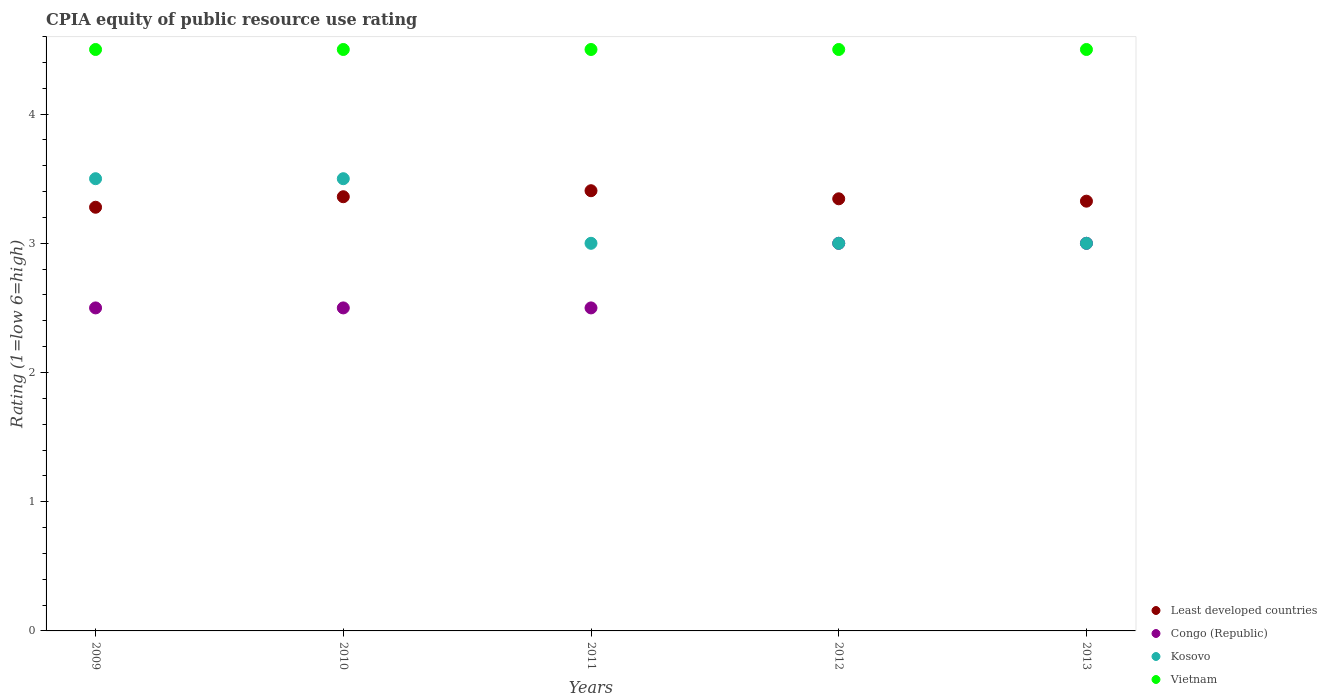How many different coloured dotlines are there?
Offer a terse response. 4. What is the CPIA rating in Least developed countries in 2009?
Your answer should be very brief. 3.28. Across all years, what is the minimum CPIA rating in Vietnam?
Provide a short and direct response. 4.5. In which year was the CPIA rating in Kosovo maximum?
Provide a succinct answer. 2009. In which year was the CPIA rating in Congo (Republic) minimum?
Your answer should be very brief. 2009. What is the difference between the CPIA rating in Least developed countries in 2011 and that in 2013?
Make the answer very short. 0.08. What is the average CPIA rating in Least developed countries per year?
Provide a succinct answer. 3.34. In the year 2010, what is the difference between the CPIA rating in Congo (Republic) and CPIA rating in Vietnam?
Provide a succinct answer. -2. Is the difference between the CPIA rating in Congo (Republic) in 2011 and 2012 greater than the difference between the CPIA rating in Vietnam in 2011 and 2012?
Provide a short and direct response. No. What is the difference between the highest and the lowest CPIA rating in Vietnam?
Your answer should be compact. 0. Is the sum of the CPIA rating in Congo (Republic) in 2010 and 2013 greater than the maximum CPIA rating in Least developed countries across all years?
Ensure brevity in your answer.  Yes. Is it the case that in every year, the sum of the CPIA rating in Congo (Republic) and CPIA rating in Kosovo  is greater than the CPIA rating in Least developed countries?
Make the answer very short. Yes. Are the values on the major ticks of Y-axis written in scientific E-notation?
Your answer should be very brief. No. How are the legend labels stacked?
Your response must be concise. Vertical. What is the title of the graph?
Provide a short and direct response. CPIA equity of public resource use rating. What is the label or title of the Y-axis?
Make the answer very short. Rating (1=low 6=high). What is the Rating (1=low 6=high) in Least developed countries in 2009?
Your answer should be compact. 3.28. What is the Rating (1=low 6=high) in Vietnam in 2009?
Provide a succinct answer. 4.5. What is the Rating (1=low 6=high) in Least developed countries in 2010?
Provide a succinct answer. 3.36. What is the Rating (1=low 6=high) in Least developed countries in 2011?
Offer a very short reply. 3.41. What is the Rating (1=low 6=high) in Vietnam in 2011?
Your answer should be compact. 4.5. What is the Rating (1=low 6=high) in Least developed countries in 2012?
Give a very brief answer. 3.34. What is the Rating (1=low 6=high) of Congo (Republic) in 2012?
Provide a short and direct response. 3. What is the Rating (1=low 6=high) of Vietnam in 2012?
Offer a terse response. 4.5. What is the Rating (1=low 6=high) in Least developed countries in 2013?
Ensure brevity in your answer.  3.33. What is the Rating (1=low 6=high) of Vietnam in 2013?
Give a very brief answer. 4.5. Across all years, what is the maximum Rating (1=low 6=high) of Least developed countries?
Offer a terse response. 3.41. Across all years, what is the maximum Rating (1=low 6=high) in Kosovo?
Your answer should be compact. 3.5. Across all years, what is the maximum Rating (1=low 6=high) of Vietnam?
Offer a terse response. 4.5. Across all years, what is the minimum Rating (1=low 6=high) in Least developed countries?
Offer a very short reply. 3.28. Across all years, what is the minimum Rating (1=low 6=high) of Vietnam?
Offer a very short reply. 4.5. What is the total Rating (1=low 6=high) of Least developed countries in the graph?
Keep it short and to the point. 16.72. What is the total Rating (1=low 6=high) of Congo (Republic) in the graph?
Ensure brevity in your answer.  13.5. What is the total Rating (1=low 6=high) in Vietnam in the graph?
Your answer should be very brief. 22.5. What is the difference between the Rating (1=low 6=high) of Least developed countries in 2009 and that in 2010?
Ensure brevity in your answer.  -0.08. What is the difference between the Rating (1=low 6=high) in Congo (Republic) in 2009 and that in 2010?
Provide a short and direct response. 0. What is the difference between the Rating (1=low 6=high) of Kosovo in 2009 and that in 2010?
Give a very brief answer. 0. What is the difference between the Rating (1=low 6=high) in Vietnam in 2009 and that in 2010?
Make the answer very short. 0. What is the difference between the Rating (1=low 6=high) of Least developed countries in 2009 and that in 2011?
Give a very brief answer. -0.13. What is the difference between the Rating (1=low 6=high) of Vietnam in 2009 and that in 2011?
Offer a very short reply. 0. What is the difference between the Rating (1=low 6=high) in Least developed countries in 2009 and that in 2012?
Provide a short and direct response. -0.07. What is the difference between the Rating (1=low 6=high) of Least developed countries in 2009 and that in 2013?
Your answer should be very brief. -0.05. What is the difference between the Rating (1=low 6=high) in Kosovo in 2009 and that in 2013?
Ensure brevity in your answer.  0.5. What is the difference between the Rating (1=low 6=high) of Least developed countries in 2010 and that in 2011?
Make the answer very short. -0.05. What is the difference between the Rating (1=low 6=high) of Least developed countries in 2010 and that in 2012?
Ensure brevity in your answer.  0.02. What is the difference between the Rating (1=low 6=high) in Vietnam in 2010 and that in 2012?
Ensure brevity in your answer.  0. What is the difference between the Rating (1=low 6=high) of Least developed countries in 2010 and that in 2013?
Give a very brief answer. 0.03. What is the difference between the Rating (1=low 6=high) in Congo (Republic) in 2010 and that in 2013?
Make the answer very short. -0.5. What is the difference between the Rating (1=low 6=high) of Vietnam in 2010 and that in 2013?
Your answer should be compact. 0. What is the difference between the Rating (1=low 6=high) of Least developed countries in 2011 and that in 2012?
Offer a terse response. 0.06. What is the difference between the Rating (1=low 6=high) in Congo (Republic) in 2011 and that in 2012?
Your response must be concise. -0.5. What is the difference between the Rating (1=low 6=high) in Kosovo in 2011 and that in 2012?
Your answer should be compact. 0. What is the difference between the Rating (1=low 6=high) in Least developed countries in 2011 and that in 2013?
Make the answer very short. 0.08. What is the difference between the Rating (1=low 6=high) in Congo (Republic) in 2011 and that in 2013?
Offer a very short reply. -0.5. What is the difference between the Rating (1=low 6=high) of Least developed countries in 2012 and that in 2013?
Your response must be concise. 0.02. What is the difference between the Rating (1=low 6=high) of Kosovo in 2012 and that in 2013?
Your response must be concise. 0. What is the difference between the Rating (1=low 6=high) of Least developed countries in 2009 and the Rating (1=low 6=high) of Congo (Republic) in 2010?
Make the answer very short. 0.78. What is the difference between the Rating (1=low 6=high) in Least developed countries in 2009 and the Rating (1=low 6=high) in Kosovo in 2010?
Provide a short and direct response. -0.22. What is the difference between the Rating (1=low 6=high) in Least developed countries in 2009 and the Rating (1=low 6=high) in Vietnam in 2010?
Make the answer very short. -1.22. What is the difference between the Rating (1=low 6=high) of Congo (Republic) in 2009 and the Rating (1=low 6=high) of Kosovo in 2010?
Your response must be concise. -1. What is the difference between the Rating (1=low 6=high) in Kosovo in 2009 and the Rating (1=low 6=high) in Vietnam in 2010?
Make the answer very short. -1. What is the difference between the Rating (1=low 6=high) of Least developed countries in 2009 and the Rating (1=low 6=high) of Congo (Republic) in 2011?
Your response must be concise. 0.78. What is the difference between the Rating (1=low 6=high) in Least developed countries in 2009 and the Rating (1=low 6=high) in Kosovo in 2011?
Provide a succinct answer. 0.28. What is the difference between the Rating (1=low 6=high) in Least developed countries in 2009 and the Rating (1=low 6=high) in Vietnam in 2011?
Provide a succinct answer. -1.22. What is the difference between the Rating (1=low 6=high) in Congo (Republic) in 2009 and the Rating (1=low 6=high) in Kosovo in 2011?
Your answer should be very brief. -0.5. What is the difference between the Rating (1=low 6=high) of Least developed countries in 2009 and the Rating (1=low 6=high) of Congo (Republic) in 2012?
Offer a terse response. 0.28. What is the difference between the Rating (1=low 6=high) of Least developed countries in 2009 and the Rating (1=low 6=high) of Kosovo in 2012?
Keep it short and to the point. 0.28. What is the difference between the Rating (1=low 6=high) in Least developed countries in 2009 and the Rating (1=low 6=high) in Vietnam in 2012?
Provide a short and direct response. -1.22. What is the difference between the Rating (1=low 6=high) in Congo (Republic) in 2009 and the Rating (1=low 6=high) in Kosovo in 2012?
Provide a succinct answer. -0.5. What is the difference between the Rating (1=low 6=high) of Congo (Republic) in 2009 and the Rating (1=low 6=high) of Vietnam in 2012?
Offer a terse response. -2. What is the difference between the Rating (1=low 6=high) of Kosovo in 2009 and the Rating (1=low 6=high) of Vietnam in 2012?
Your answer should be compact. -1. What is the difference between the Rating (1=low 6=high) of Least developed countries in 2009 and the Rating (1=low 6=high) of Congo (Republic) in 2013?
Give a very brief answer. 0.28. What is the difference between the Rating (1=low 6=high) in Least developed countries in 2009 and the Rating (1=low 6=high) in Kosovo in 2013?
Your answer should be very brief. 0.28. What is the difference between the Rating (1=low 6=high) of Least developed countries in 2009 and the Rating (1=low 6=high) of Vietnam in 2013?
Your answer should be very brief. -1.22. What is the difference between the Rating (1=low 6=high) in Congo (Republic) in 2009 and the Rating (1=low 6=high) in Vietnam in 2013?
Give a very brief answer. -2. What is the difference between the Rating (1=low 6=high) in Least developed countries in 2010 and the Rating (1=low 6=high) in Congo (Republic) in 2011?
Make the answer very short. 0.86. What is the difference between the Rating (1=low 6=high) in Least developed countries in 2010 and the Rating (1=low 6=high) in Kosovo in 2011?
Provide a succinct answer. 0.36. What is the difference between the Rating (1=low 6=high) of Least developed countries in 2010 and the Rating (1=low 6=high) of Vietnam in 2011?
Make the answer very short. -1.14. What is the difference between the Rating (1=low 6=high) in Congo (Republic) in 2010 and the Rating (1=low 6=high) in Kosovo in 2011?
Make the answer very short. -0.5. What is the difference between the Rating (1=low 6=high) of Least developed countries in 2010 and the Rating (1=low 6=high) of Congo (Republic) in 2012?
Your answer should be compact. 0.36. What is the difference between the Rating (1=low 6=high) of Least developed countries in 2010 and the Rating (1=low 6=high) of Kosovo in 2012?
Ensure brevity in your answer.  0.36. What is the difference between the Rating (1=low 6=high) in Least developed countries in 2010 and the Rating (1=low 6=high) in Vietnam in 2012?
Give a very brief answer. -1.14. What is the difference between the Rating (1=low 6=high) in Least developed countries in 2010 and the Rating (1=low 6=high) in Congo (Republic) in 2013?
Keep it short and to the point. 0.36. What is the difference between the Rating (1=low 6=high) of Least developed countries in 2010 and the Rating (1=low 6=high) of Kosovo in 2013?
Your response must be concise. 0.36. What is the difference between the Rating (1=low 6=high) in Least developed countries in 2010 and the Rating (1=low 6=high) in Vietnam in 2013?
Your answer should be very brief. -1.14. What is the difference between the Rating (1=low 6=high) of Congo (Republic) in 2010 and the Rating (1=low 6=high) of Kosovo in 2013?
Offer a terse response. -0.5. What is the difference between the Rating (1=low 6=high) in Congo (Republic) in 2010 and the Rating (1=low 6=high) in Vietnam in 2013?
Offer a very short reply. -2. What is the difference between the Rating (1=low 6=high) in Kosovo in 2010 and the Rating (1=low 6=high) in Vietnam in 2013?
Provide a short and direct response. -1. What is the difference between the Rating (1=low 6=high) in Least developed countries in 2011 and the Rating (1=low 6=high) in Congo (Republic) in 2012?
Offer a terse response. 0.41. What is the difference between the Rating (1=low 6=high) of Least developed countries in 2011 and the Rating (1=low 6=high) of Kosovo in 2012?
Provide a succinct answer. 0.41. What is the difference between the Rating (1=low 6=high) in Least developed countries in 2011 and the Rating (1=low 6=high) in Vietnam in 2012?
Your answer should be very brief. -1.09. What is the difference between the Rating (1=low 6=high) of Congo (Republic) in 2011 and the Rating (1=low 6=high) of Vietnam in 2012?
Provide a succinct answer. -2. What is the difference between the Rating (1=low 6=high) in Kosovo in 2011 and the Rating (1=low 6=high) in Vietnam in 2012?
Your answer should be compact. -1.5. What is the difference between the Rating (1=low 6=high) of Least developed countries in 2011 and the Rating (1=low 6=high) of Congo (Republic) in 2013?
Offer a terse response. 0.41. What is the difference between the Rating (1=low 6=high) in Least developed countries in 2011 and the Rating (1=low 6=high) in Kosovo in 2013?
Offer a terse response. 0.41. What is the difference between the Rating (1=low 6=high) in Least developed countries in 2011 and the Rating (1=low 6=high) in Vietnam in 2013?
Keep it short and to the point. -1.09. What is the difference between the Rating (1=low 6=high) of Least developed countries in 2012 and the Rating (1=low 6=high) of Congo (Republic) in 2013?
Your response must be concise. 0.34. What is the difference between the Rating (1=low 6=high) of Least developed countries in 2012 and the Rating (1=low 6=high) of Kosovo in 2013?
Provide a short and direct response. 0.34. What is the difference between the Rating (1=low 6=high) in Least developed countries in 2012 and the Rating (1=low 6=high) in Vietnam in 2013?
Your answer should be compact. -1.16. What is the difference between the Rating (1=low 6=high) of Kosovo in 2012 and the Rating (1=low 6=high) of Vietnam in 2013?
Provide a succinct answer. -1.5. What is the average Rating (1=low 6=high) of Least developed countries per year?
Keep it short and to the point. 3.34. What is the average Rating (1=low 6=high) of Congo (Republic) per year?
Make the answer very short. 2.7. In the year 2009, what is the difference between the Rating (1=low 6=high) of Least developed countries and Rating (1=low 6=high) of Congo (Republic)?
Your answer should be compact. 0.78. In the year 2009, what is the difference between the Rating (1=low 6=high) of Least developed countries and Rating (1=low 6=high) of Kosovo?
Give a very brief answer. -0.22. In the year 2009, what is the difference between the Rating (1=low 6=high) in Least developed countries and Rating (1=low 6=high) in Vietnam?
Provide a short and direct response. -1.22. In the year 2010, what is the difference between the Rating (1=low 6=high) of Least developed countries and Rating (1=low 6=high) of Congo (Republic)?
Provide a succinct answer. 0.86. In the year 2010, what is the difference between the Rating (1=low 6=high) of Least developed countries and Rating (1=low 6=high) of Kosovo?
Ensure brevity in your answer.  -0.14. In the year 2010, what is the difference between the Rating (1=low 6=high) in Least developed countries and Rating (1=low 6=high) in Vietnam?
Provide a succinct answer. -1.14. In the year 2011, what is the difference between the Rating (1=low 6=high) of Least developed countries and Rating (1=low 6=high) of Congo (Republic)?
Ensure brevity in your answer.  0.91. In the year 2011, what is the difference between the Rating (1=low 6=high) of Least developed countries and Rating (1=low 6=high) of Kosovo?
Give a very brief answer. 0.41. In the year 2011, what is the difference between the Rating (1=low 6=high) of Least developed countries and Rating (1=low 6=high) of Vietnam?
Ensure brevity in your answer.  -1.09. In the year 2011, what is the difference between the Rating (1=low 6=high) of Congo (Republic) and Rating (1=low 6=high) of Kosovo?
Keep it short and to the point. -0.5. In the year 2011, what is the difference between the Rating (1=low 6=high) of Congo (Republic) and Rating (1=low 6=high) of Vietnam?
Your answer should be compact. -2. In the year 2012, what is the difference between the Rating (1=low 6=high) in Least developed countries and Rating (1=low 6=high) in Congo (Republic)?
Your answer should be very brief. 0.34. In the year 2012, what is the difference between the Rating (1=low 6=high) in Least developed countries and Rating (1=low 6=high) in Kosovo?
Offer a terse response. 0.34. In the year 2012, what is the difference between the Rating (1=low 6=high) in Least developed countries and Rating (1=low 6=high) in Vietnam?
Offer a terse response. -1.16. In the year 2012, what is the difference between the Rating (1=low 6=high) of Congo (Republic) and Rating (1=low 6=high) of Kosovo?
Keep it short and to the point. 0. In the year 2012, what is the difference between the Rating (1=low 6=high) of Congo (Republic) and Rating (1=low 6=high) of Vietnam?
Your answer should be compact. -1.5. In the year 2013, what is the difference between the Rating (1=low 6=high) of Least developed countries and Rating (1=low 6=high) of Congo (Republic)?
Your response must be concise. 0.33. In the year 2013, what is the difference between the Rating (1=low 6=high) of Least developed countries and Rating (1=low 6=high) of Kosovo?
Your response must be concise. 0.33. In the year 2013, what is the difference between the Rating (1=low 6=high) in Least developed countries and Rating (1=low 6=high) in Vietnam?
Your answer should be very brief. -1.17. In the year 2013, what is the difference between the Rating (1=low 6=high) of Congo (Republic) and Rating (1=low 6=high) of Kosovo?
Offer a terse response. 0. In the year 2013, what is the difference between the Rating (1=low 6=high) in Congo (Republic) and Rating (1=low 6=high) in Vietnam?
Your answer should be compact. -1.5. What is the ratio of the Rating (1=low 6=high) in Least developed countries in 2009 to that in 2010?
Make the answer very short. 0.98. What is the ratio of the Rating (1=low 6=high) in Congo (Republic) in 2009 to that in 2010?
Ensure brevity in your answer.  1. What is the ratio of the Rating (1=low 6=high) of Least developed countries in 2009 to that in 2011?
Offer a terse response. 0.96. What is the ratio of the Rating (1=low 6=high) of Congo (Republic) in 2009 to that in 2011?
Provide a short and direct response. 1. What is the ratio of the Rating (1=low 6=high) in Least developed countries in 2009 to that in 2012?
Give a very brief answer. 0.98. What is the ratio of the Rating (1=low 6=high) of Kosovo in 2009 to that in 2012?
Offer a terse response. 1.17. What is the ratio of the Rating (1=low 6=high) in Vietnam in 2009 to that in 2012?
Your answer should be compact. 1. What is the ratio of the Rating (1=low 6=high) in Least developed countries in 2009 to that in 2013?
Keep it short and to the point. 0.99. What is the ratio of the Rating (1=low 6=high) in Congo (Republic) in 2009 to that in 2013?
Your response must be concise. 0.83. What is the ratio of the Rating (1=low 6=high) of Kosovo in 2009 to that in 2013?
Your response must be concise. 1.17. What is the ratio of the Rating (1=low 6=high) in Least developed countries in 2010 to that in 2011?
Make the answer very short. 0.99. What is the ratio of the Rating (1=low 6=high) of Congo (Republic) in 2010 to that in 2011?
Provide a succinct answer. 1. What is the ratio of the Rating (1=low 6=high) of Kosovo in 2010 to that in 2011?
Ensure brevity in your answer.  1.17. What is the ratio of the Rating (1=low 6=high) of Vietnam in 2010 to that in 2012?
Offer a very short reply. 1. What is the ratio of the Rating (1=low 6=high) in Least developed countries in 2010 to that in 2013?
Give a very brief answer. 1.01. What is the ratio of the Rating (1=low 6=high) in Vietnam in 2010 to that in 2013?
Provide a short and direct response. 1. What is the ratio of the Rating (1=low 6=high) of Least developed countries in 2011 to that in 2012?
Your answer should be compact. 1.02. What is the ratio of the Rating (1=low 6=high) of Congo (Republic) in 2011 to that in 2012?
Your response must be concise. 0.83. What is the ratio of the Rating (1=low 6=high) in Vietnam in 2011 to that in 2012?
Keep it short and to the point. 1. What is the ratio of the Rating (1=low 6=high) in Least developed countries in 2011 to that in 2013?
Offer a terse response. 1.02. What is the ratio of the Rating (1=low 6=high) in Vietnam in 2011 to that in 2013?
Offer a terse response. 1. What is the ratio of the Rating (1=low 6=high) in Congo (Republic) in 2012 to that in 2013?
Your answer should be very brief. 1. What is the difference between the highest and the second highest Rating (1=low 6=high) of Least developed countries?
Ensure brevity in your answer.  0.05. What is the difference between the highest and the second highest Rating (1=low 6=high) in Congo (Republic)?
Your answer should be very brief. 0. What is the difference between the highest and the second highest Rating (1=low 6=high) of Vietnam?
Provide a short and direct response. 0. What is the difference between the highest and the lowest Rating (1=low 6=high) in Least developed countries?
Provide a short and direct response. 0.13. What is the difference between the highest and the lowest Rating (1=low 6=high) in Vietnam?
Offer a very short reply. 0. 